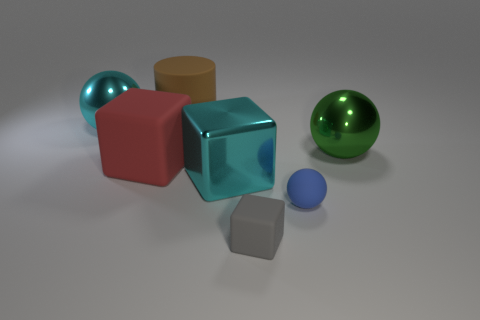Is there any other thing that has the same color as the big shiny block?
Offer a terse response. Yes. There is a tiny blue object that is made of the same material as the big red thing; what is its shape?
Your response must be concise. Sphere. Do the big ball to the left of the big cylinder and the red thing that is left of the brown cylinder have the same material?
Give a very brief answer. No. What number of objects are either green things or blocks that are behind the tiny gray matte cube?
Give a very brief answer. 3. The large shiny object that is the same color as the large metallic block is what shape?
Your answer should be very brief. Sphere. What material is the small blue sphere?
Your response must be concise. Rubber. Do the small gray cube and the cylinder have the same material?
Provide a short and direct response. Yes. What number of metal objects are either cyan things or cylinders?
Offer a terse response. 2. What shape is the cyan metallic object that is on the right side of the big cylinder?
Your response must be concise. Cube. There is a sphere that is the same material as the big brown cylinder; what is its size?
Offer a very short reply. Small. 